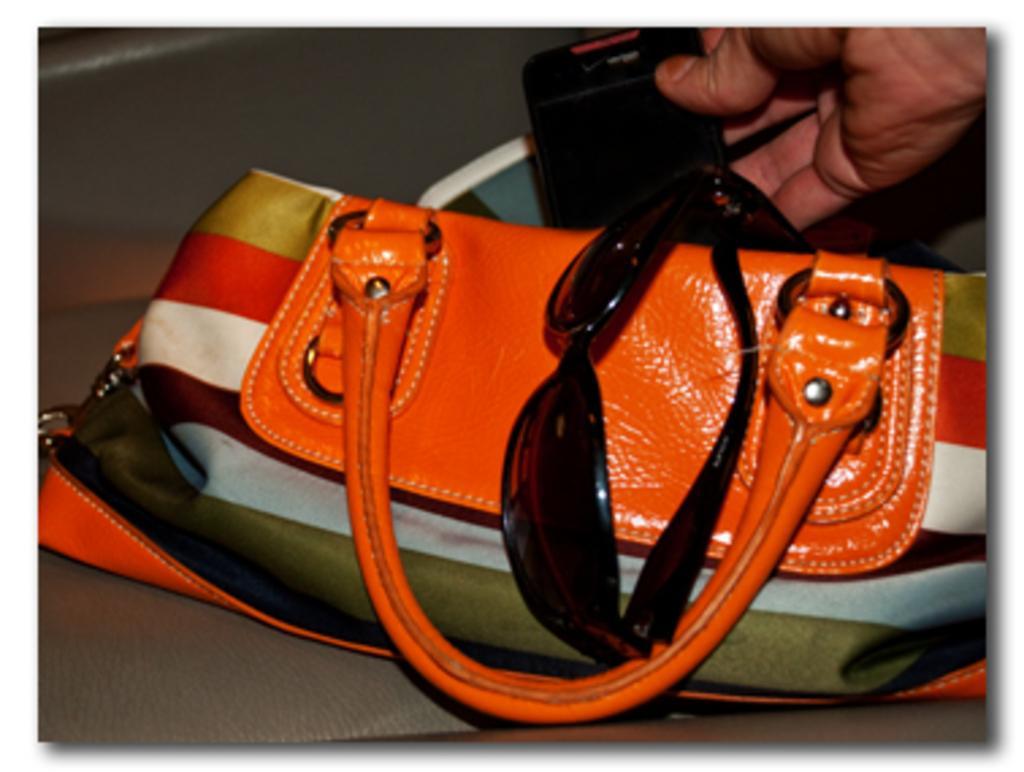In one or two sentences, can you explain what this image depicts? There is a hand bag which contains goggles and mobile in it. 